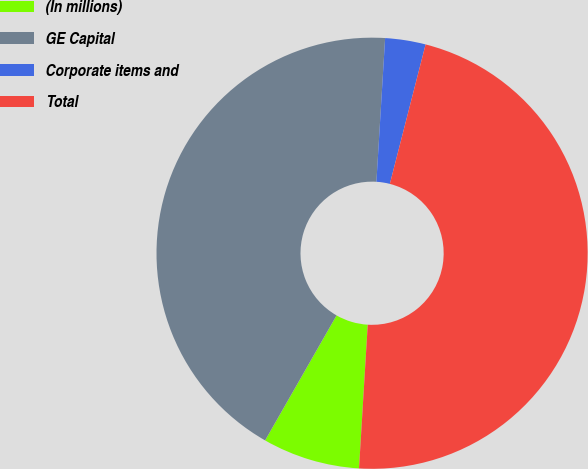Convert chart to OTSL. <chart><loc_0><loc_0><loc_500><loc_500><pie_chart><fcel>(In millions)<fcel>GE Capital<fcel>Corporate items and<fcel>Total<nl><fcel>7.3%<fcel>42.7%<fcel>3.03%<fcel>46.97%<nl></chart> 